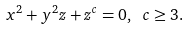<formula> <loc_0><loc_0><loc_500><loc_500>x ^ { 2 } + y ^ { 2 } z + z ^ { c } = 0 , \text { } c \geq 3 .</formula> 